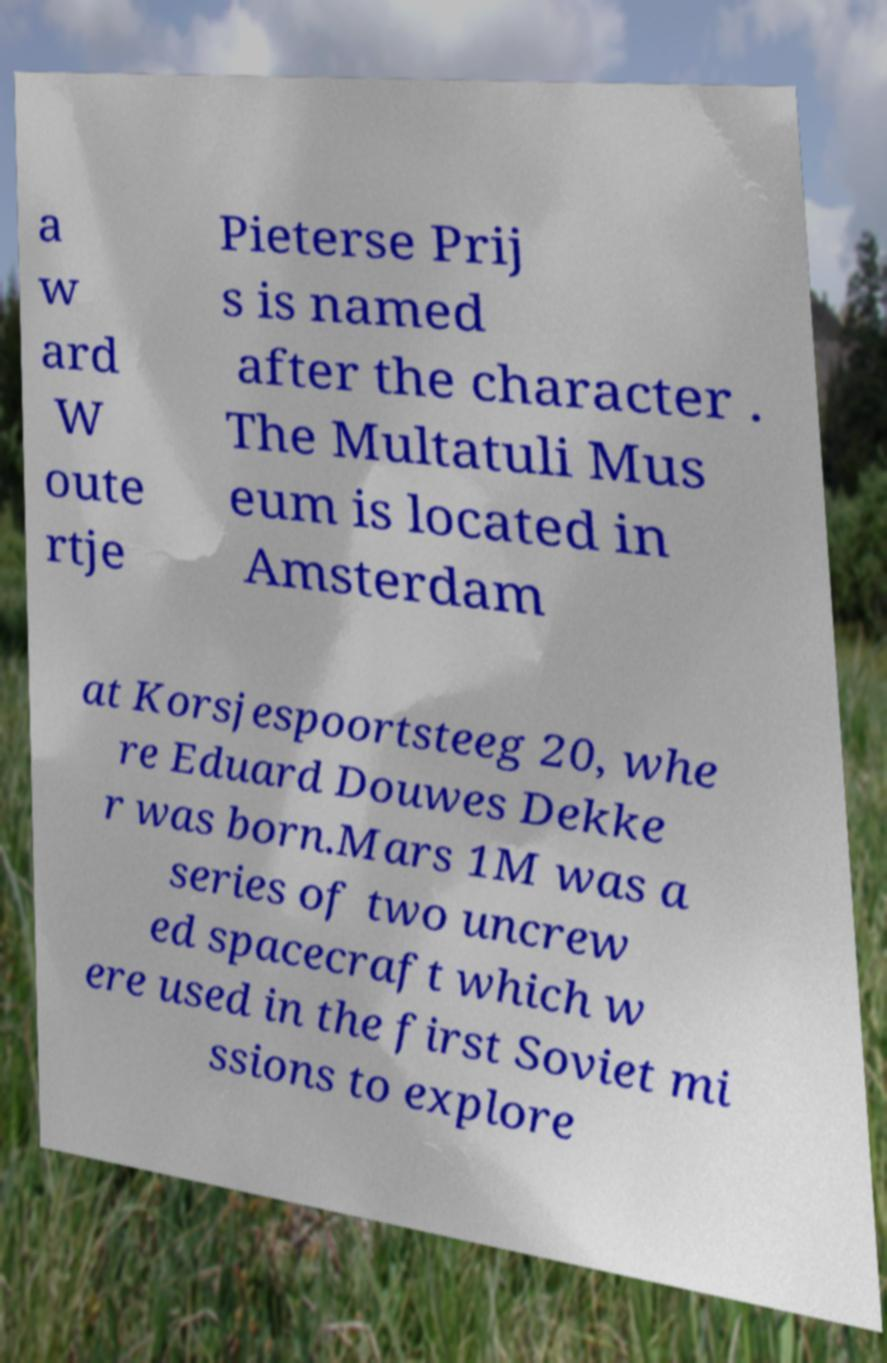Can you read and provide the text displayed in the image?This photo seems to have some interesting text. Can you extract and type it out for me? a w ard W oute rtje Pieterse Prij s is named after the character . The Multatuli Mus eum is located in Amsterdam at Korsjespoortsteeg 20, whe re Eduard Douwes Dekke r was born.Mars 1M was a series of two uncrew ed spacecraft which w ere used in the first Soviet mi ssions to explore 